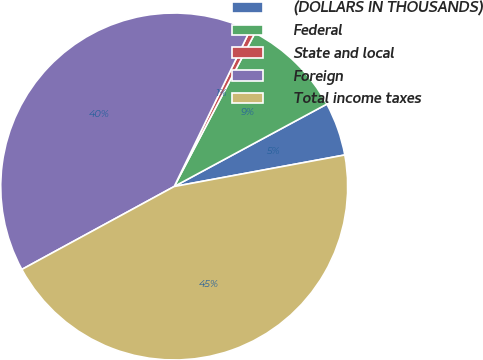<chart> <loc_0><loc_0><loc_500><loc_500><pie_chart><fcel>(DOLLARS IN THOUSANDS)<fcel>Federal<fcel>State and local<fcel>Foreign<fcel>Total income taxes<nl><fcel>4.97%<fcel>9.41%<fcel>0.52%<fcel>40.12%<fcel>44.97%<nl></chart> 